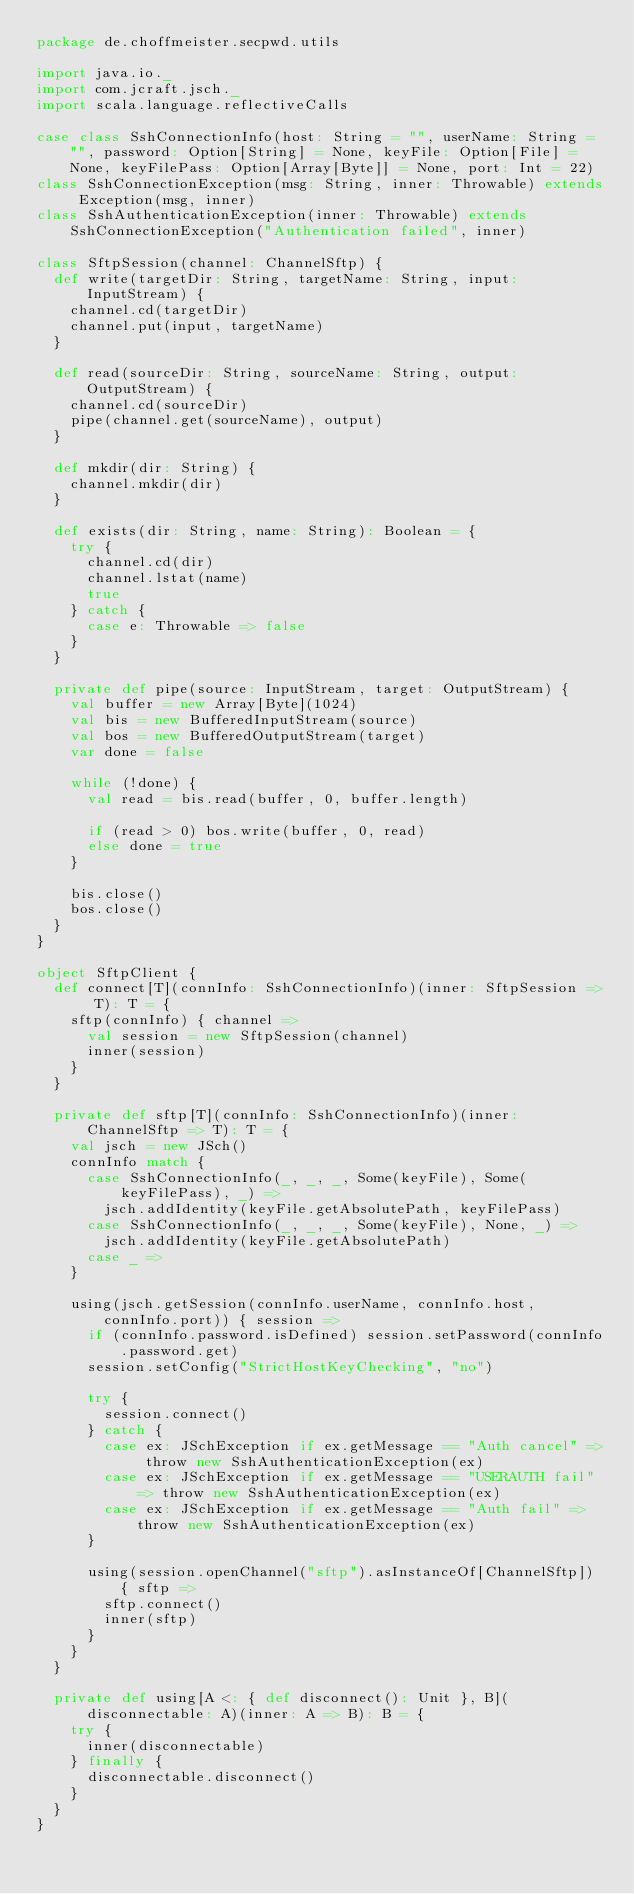Convert code to text. <code><loc_0><loc_0><loc_500><loc_500><_Scala_>package de.choffmeister.secpwd.utils

import java.io._
import com.jcraft.jsch._
import scala.language.reflectiveCalls

case class SshConnectionInfo(host: String = "", userName: String = "", password: Option[String] = None, keyFile: Option[File] = None, keyFilePass: Option[Array[Byte]] = None, port: Int = 22)
class SshConnectionException(msg: String, inner: Throwable) extends Exception(msg, inner)
class SshAuthenticationException(inner: Throwable) extends SshConnectionException("Authentication failed", inner)

class SftpSession(channel: ChannelSftp) {
  def write(targetDir: String, targetName: String, input: InputStream) {
    channel.cd(targetDir)
    channel.put(input, targetName)
  }

  def read(sourceDir: String, sourceName: String, output: OutputStream) {
    channel.cd(sourceDir)
    pipe(channel.get(sourceName), output)
  }

  def mkdir(dir: String) {
    channel.mkdir(dir)
  }

  def exists(dir: String, name: String): Boolean = {
    try {
      channel.cd(dir)
      channel.lstat(name)
      true
    } catch {
      case e: Throwable => false
    }
  }

  private def pipe(source: InputStream, target: OutputStream) {
    val buffer = new Array[Byte](1024)
    val bis = new BufferedInputStream(source)
    val bos = new BufferedOutputStream(target)
    var done = false

    while (!done) {
      val read = bis.read(buffer, 0, buffer.length)

      if (read > 0) bos.write(buffer, 0, read)
      else done = true
    }

    bis.close()
    bos.close()
  }
}

object SftpClient {
  def connect[T](connInfo: SshConnectionInfo)(inner: SftpSession => T): T = {
    sftp(connInfo) { channel =>
      val session = new SftpSession(channel)
      inner(session)
    }
  }

  private def sftp[T](connInfo: SshConnectionInfo)(inner: ChannelSftp => T): T = {
    val jsch = new JSch()
    connInfo match {
      case SshConnectionInfo(_, _, _, Some(keyFile), Some(keyFilePass), _) => 
        jsch.addIdentity(keyFile.getAbsolutePath, keyFilePass)
      case SshConnectionInfo(_, _, _, Some(keyFile), None, _) => 
        jsch.addIdentity(keyFile.getAbsolutePath)
      case _ =>
    }

    using(jsch.getSession(connInfo.userName, connInfo.host, connInfo.port)) { session =>
      if (connInfo.password.isDefined) session.setPassword(connInfo.password.get)
      session.setConfig("StrictHostKeyChecking", "no")

      try {
        session.connect()
      } catch {
        case ex: JSchException if ex.getMessage == "Auth cancel" => throw new SshAuthenticationException(ex)
        case ex: JSchException if ex.getMessage == "USERAUTH fail" => throw new SshAuthenticationException(ex)
        case ex: JSchException if ex.getMessage == "Auth fail" => throw new SshAuthenticationException(ex)
      }

      using(session.openChannel("sftp").asInstanceOf[ChannelSftp]) { sftp =>
        sftp.connect()
        inner(sftp)
      }
    }
  }

  private def using[A <: { def disconnect(): Unit }, B](disconnectable: A)(inner: A => B): B = {
    try {
      inner(disconnectable)
    } finally {
      disconnectable.disconnect()
    }
  }
}
</code> 